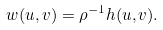<formula> <loc_0><loc_0><loc_500><loc_500>w ( u , v ) = \rho ^ { - 1 } h ( u , v ) .</formula> 